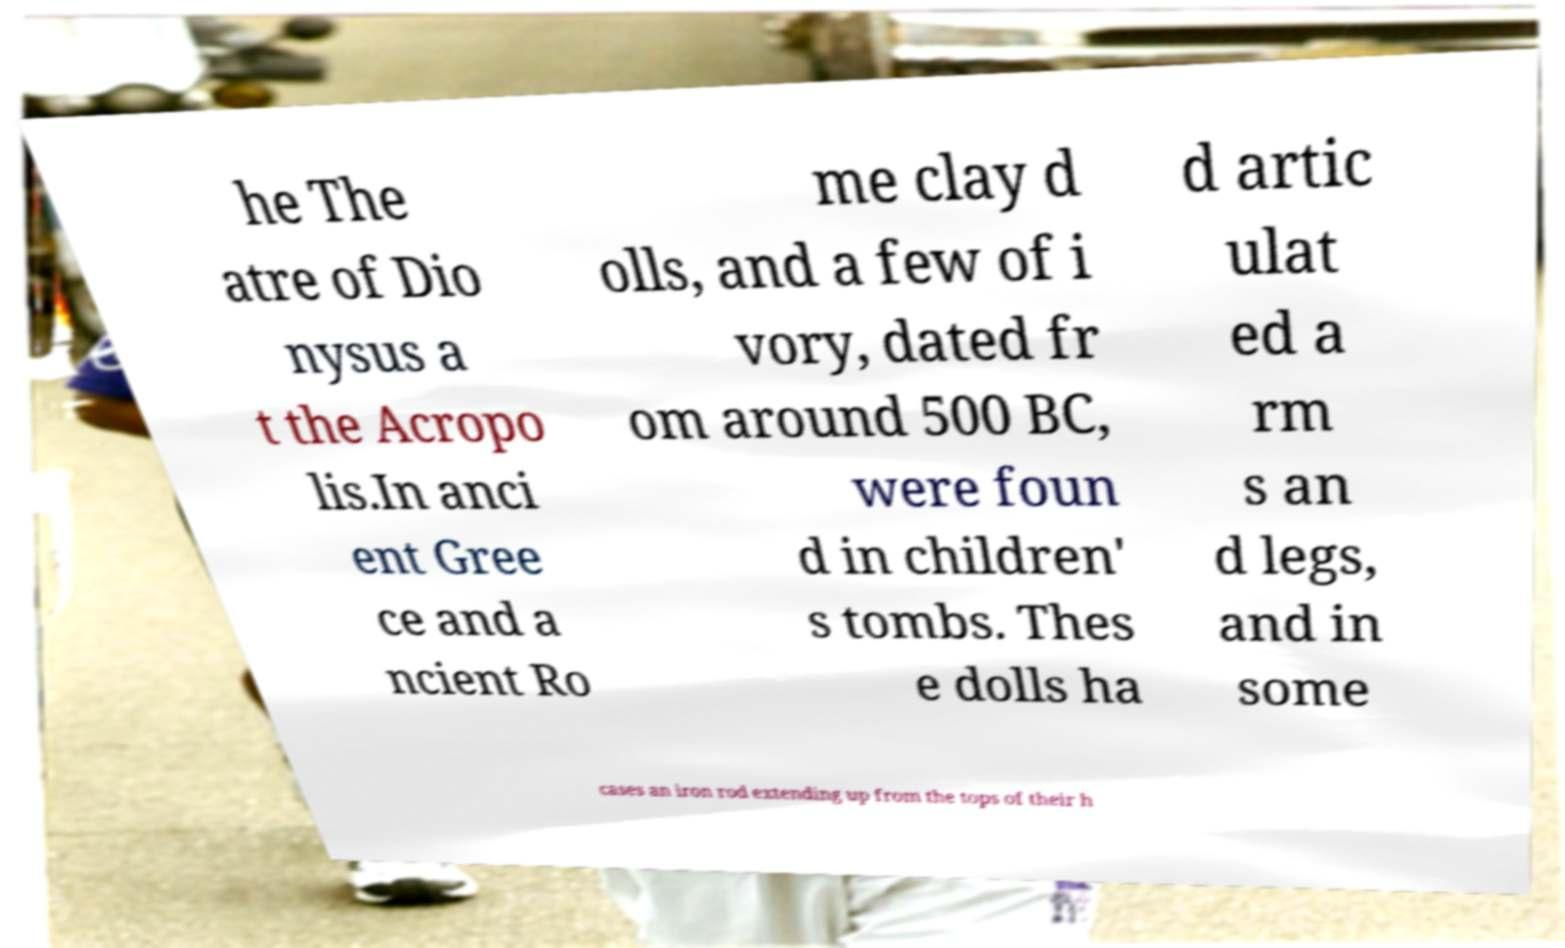For documentation purposes, I need the text within this image transcribed. Could you provide that? he The atre of Dio nysus a t the Acropo lis.In anci ent Gree ce and a ncient Ro me clay d olls, and a few of i vory, dated fr om around 500 BC, were foun d in children' s tombs. Thes e dolls ha d artic ulat ed a rm s an d legs, and in some cases an iron rod extending up from the tops of their h 